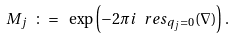<formula> <loc_0><loc_0><loc_500><loc_500>M _ { j } \ \colon = \ \exp \left ( - 2 \pi i \ r e s _ { q _ { j } = 0 } ( \nabla ) \right ) .</formula> 